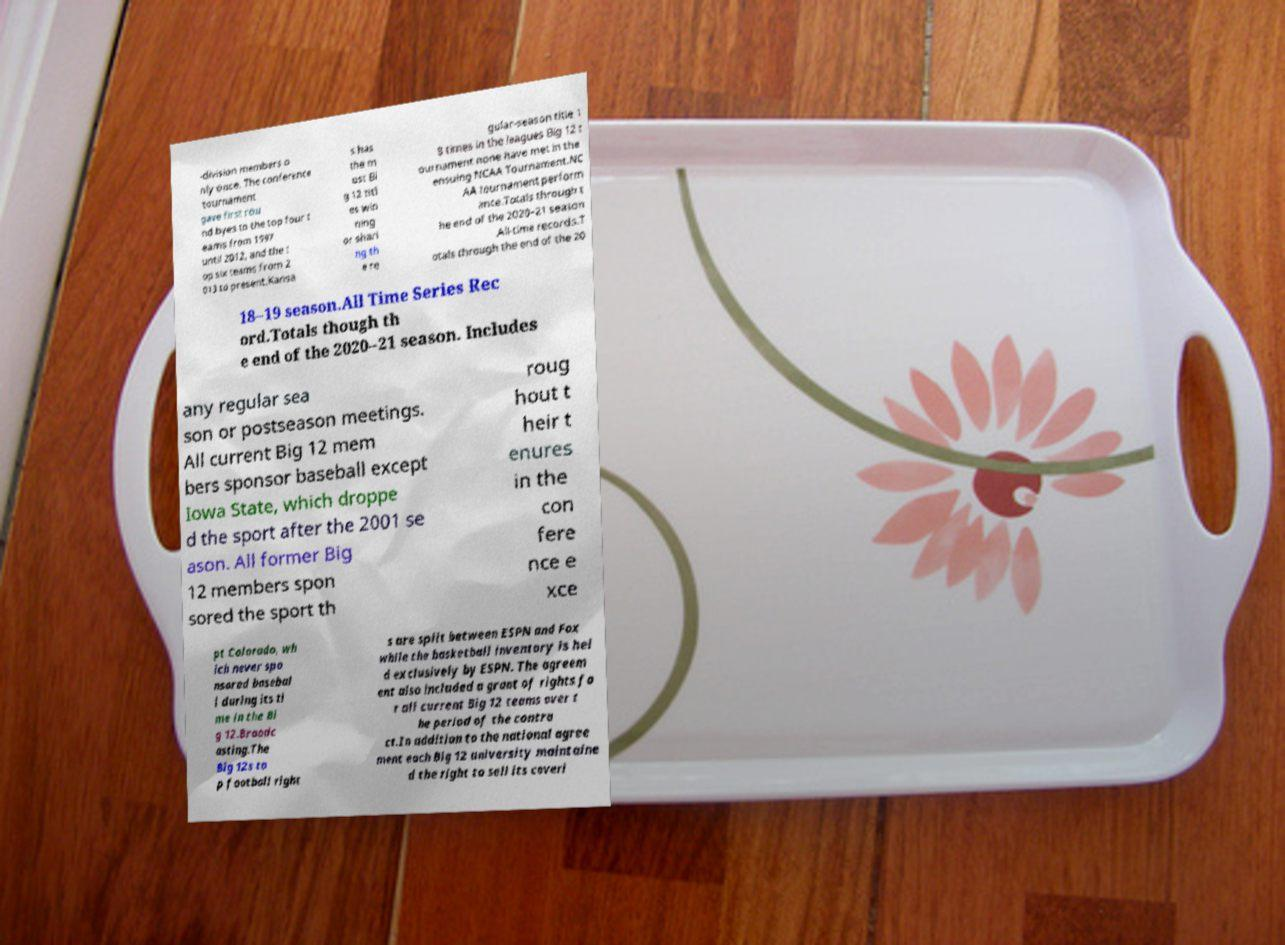Please identify and transcribe the text found in this image. -division members o nly once. The conference tournament gave first rou nd byes to the top four t eams from 1997 until 2012, and the t op six teams from 2 013 to present.Kansa s has the m ost Bi g 12 titl es win ning or shari ng th e re gular-season title 1 8 times in the leagues Big 12 t ournament none have met in the ensuing NCAA Tournament.NC AA tournament perform ance.Totals through t he end of the 2020–21 season .All-time records.T otals through the end of the 20 18–19 season.All Time Series Rec ord.Totals though th e end of the 2020–21 season. Includes any regular sea son or postseason meetings. All current Big 12 mem bers sponsor baseball except Iowa State, which droppe d the sport after the 2001 se ason. All former Big 12 members spon sored the sport th roug hout t heir t enures in the con fere nce e xce pt Colorado, wh ich never spo nsored basebal l during its ti me in the Bi g 12.Broadc asting.The Big 12s to p football right s are split between ESPN and Fox while the basketball inventory is hel d exclusively by ESPN. The agreem ent also included a grant of rights fo r all current Big 12 teams over t he period of the contra ct.In addition to the national agree ment each Big 12 university maintaine d the right to sell its coveri 